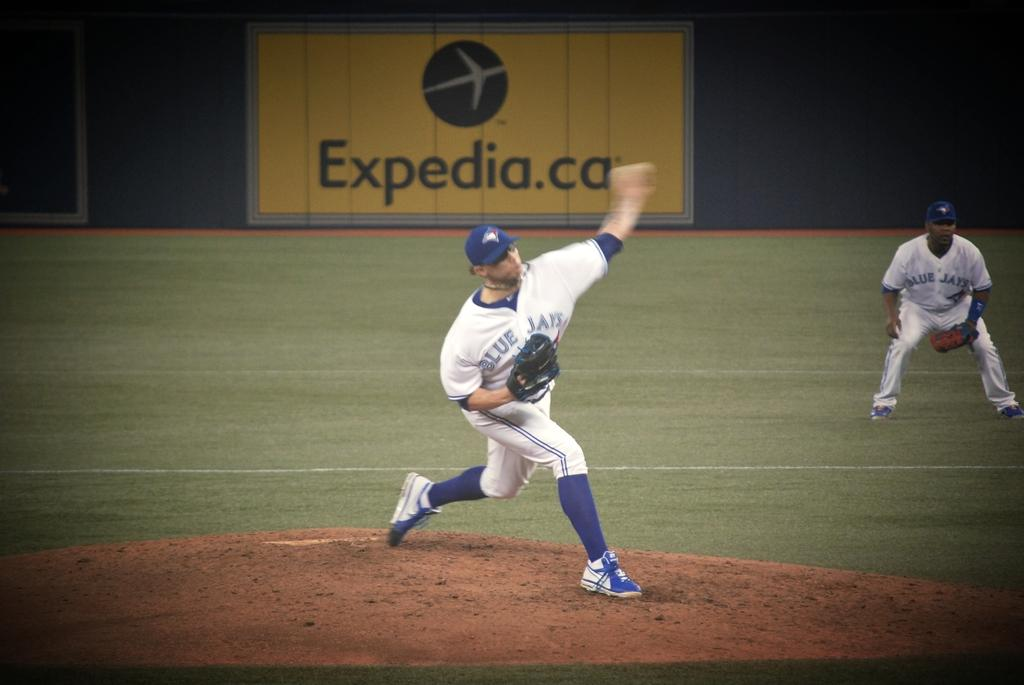Provide a one-sentence caption for the provided image. A pitcher winds up to throw the ball in front of an Expedia.ca billboard. 